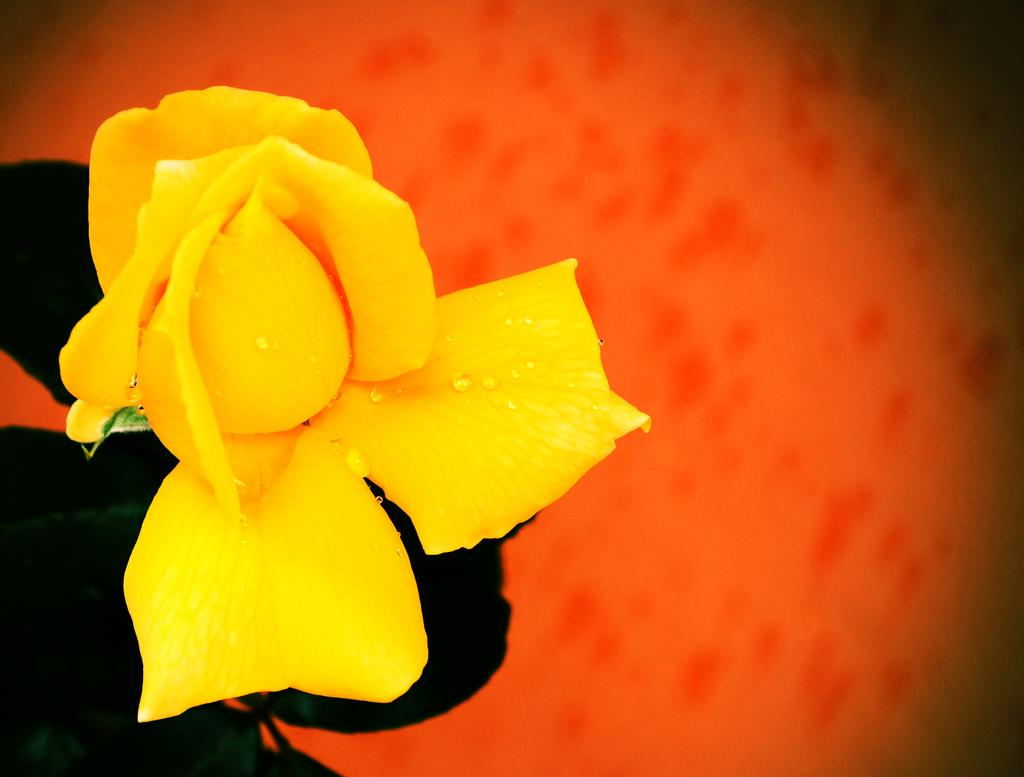What type of flower is in the foreground of the image? There is a yellow color rose flower in the foreground of the image. What else can be seen in the image besides the flower? There are leaves in the image. What can be observed about the background of the image? The background of the image has a color. What type of potato is being developed in the image? There is no potato present in the image; it features a yellow color rose flower and leaves. What kind of vessel is used to transport the flower in the image? There is no vessel present in the image; the flower is in the foreground without any container. 